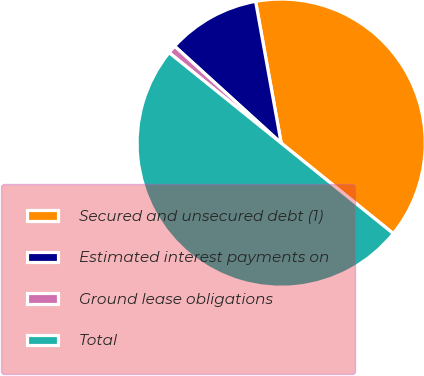Convert chart. <chart><loc_0><loc_0><loc_500><loc_500><pie_chart><fcel>Secured and unsecured debt (1)<fcel>Estimated interest payments on<fcel>Ground lease obligations<fcel>Total<nl><fcel>38.65%<fcel>10.41%<fcel>0.94%<fcel>50.01%<nl></chart> 